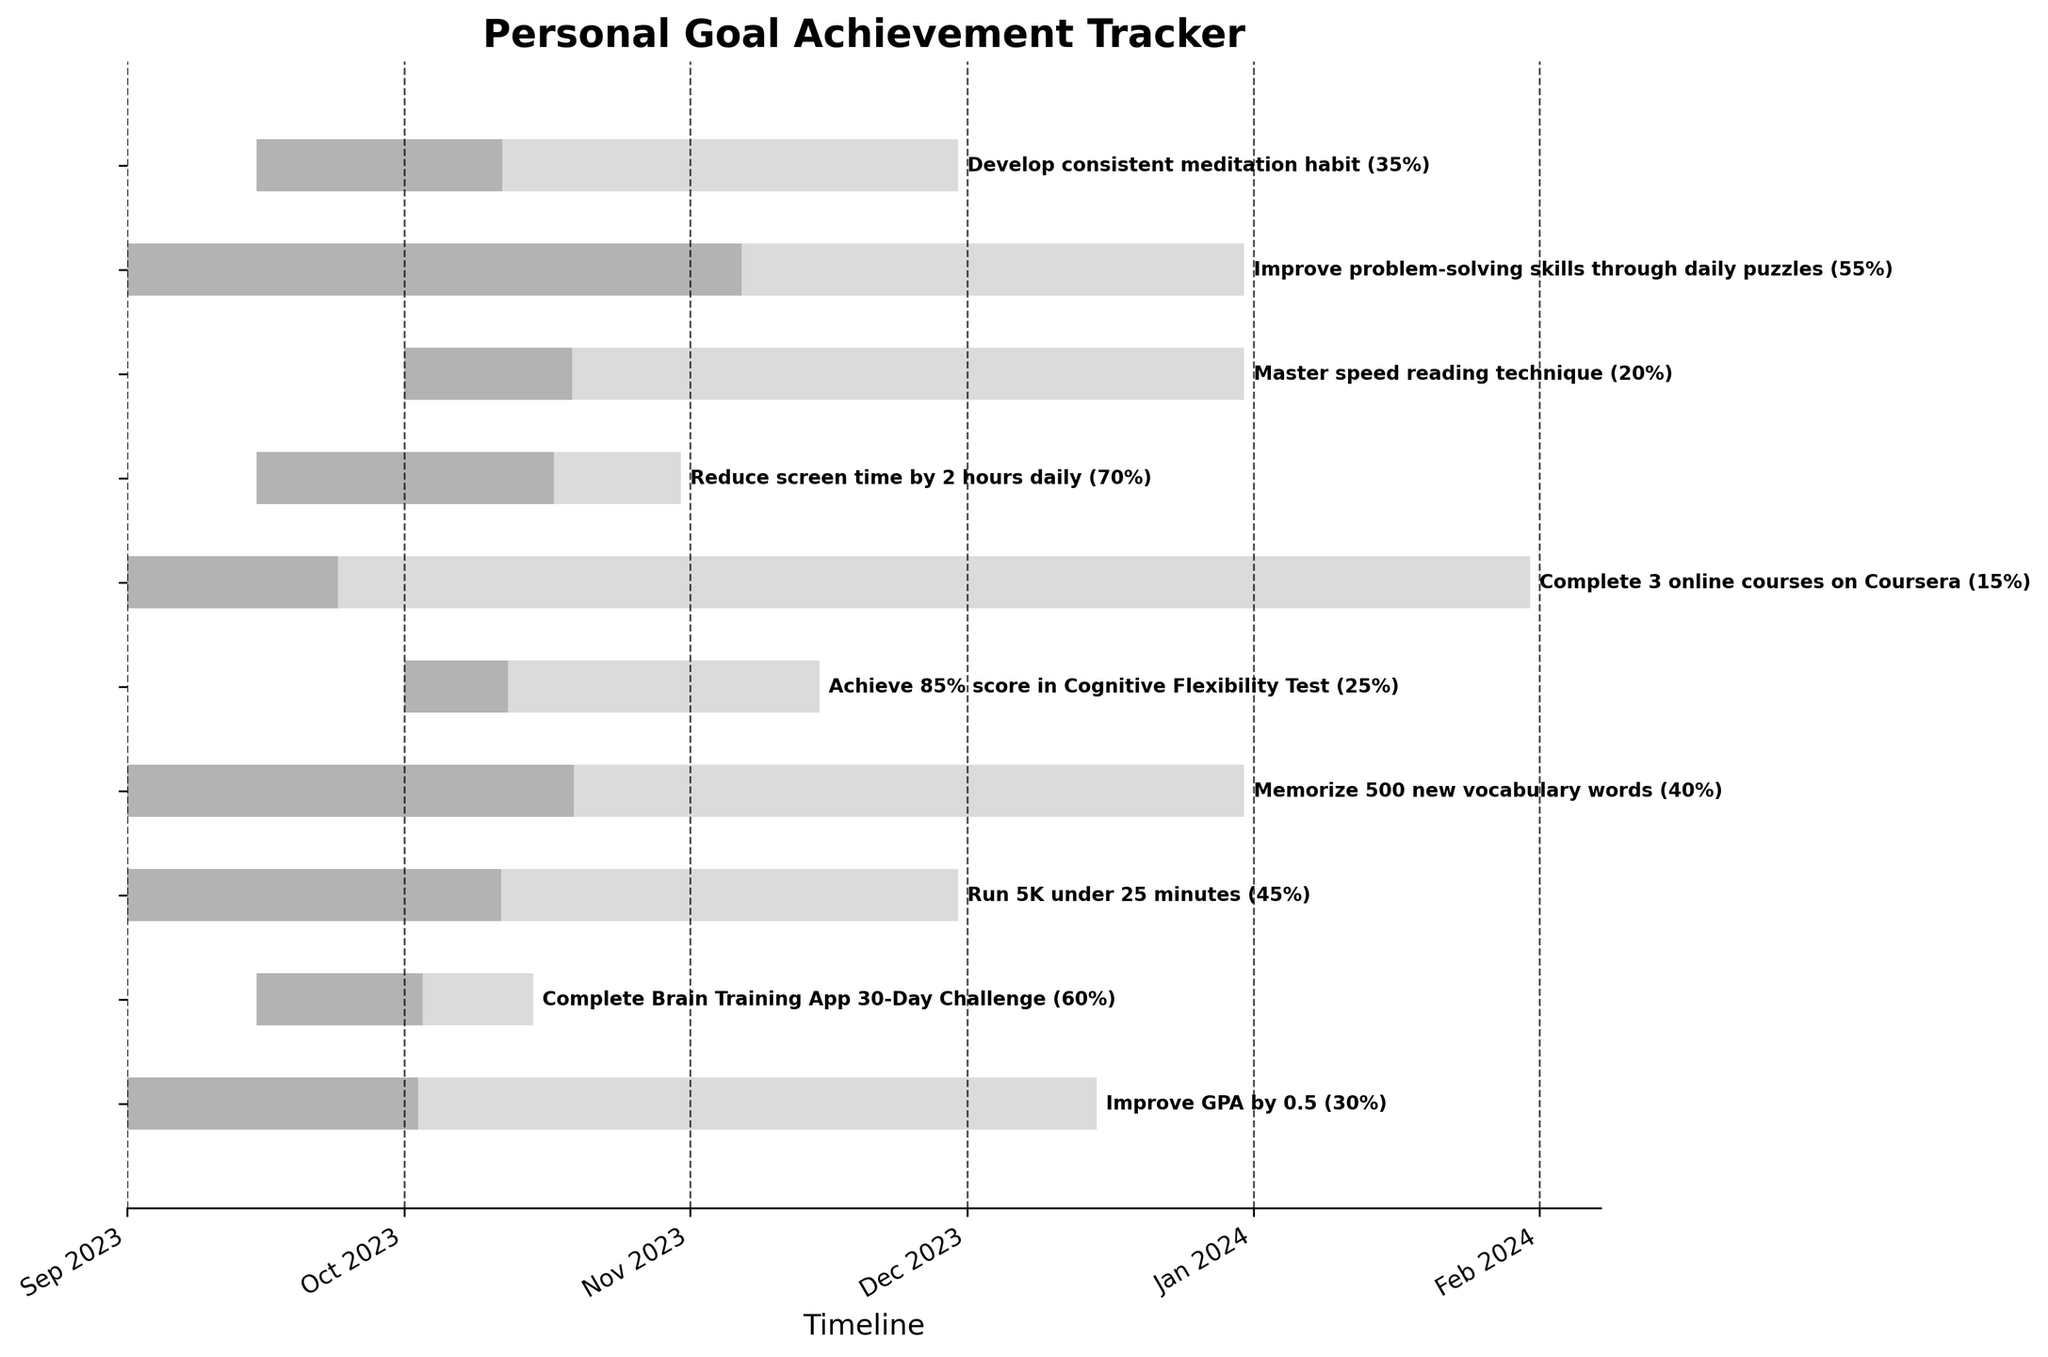What's the title of the chart? The title of the chart is the text displayed prominently at the top of the figure, summarizing what the chart represents. Typically, the title is the largest and boldest text.
Answer: Personal Goal Achievement Tracker Which task has the highest progress percentage? To determine which task has the highest progress percentage, look for the task with the longest dark gray bar within its overall timeline bar.
Answer: Reduce screen time by 2 hours daily What is the timeline range shown in the chart? The timeline range is indicated on the x-axis, and can be seen by observing the first and last major tick marks on the axis. The plotted tasks and dates further confirm this range.
Answer: Sep 2023 to Jan 2024 Which tasks start in October 2023? To find tasks starting in October 2023, check the dates at the left end of the bars. Look for bars that start in October.
Answer: Achieve 85% score in Cognitive Flexibility Test, Master speed reading technique How long is the task "Complete 3 online courses on Coursera"? Calculate the duration of the task by subtracting the start date from the end date. The start and end dates are provided and can be directly observed in the figure.
Answer: 5 months Which task has the smallest progress percentage? Look for the task with the shortest dark gray bar within its overall timeline bar. This indicates the task with the smallest percentage completed.
Answer: Complete 3 online courses on Coursera What is the combined duration of "Run 5K under 25 minutes" and "Improve GPA by 0.5"? Determine the duration of each task separately by subtracting the start date from the end date, then sum the two durations.
Answer: 5.5 months (3 months for "Run 5K under 25 minutes" and 2.5 months for "Improve GPA by 0.5") Which tasks have progress percentages greater than 50%? Check each task's progress percentage shown next to the gray progress bar and list those that have percentages over 50%.
Answer: Complete Brain Training App 30-Day Challenge, Reduce screen time by 2 hours daily, Improve problem-solving skills through daily puzzles How many tasks are focused on cognitive improvement? Identify and count the tasks based on their descriptions that suggest cognitive improvements.
Answer: 4 (Complete Brain Training App 30-Day Challenge, Achieve 85% score in Cognitive Flexibility Test, Master speed reading technique, Improve problem-solving skills through daily puzzles) Which task has the latest end date? Look for the task with the bar ending furthest to the right. The end dates for tasks are displayed at the right end of the bars.
Answer: Complete 3 online courses on Coursera 